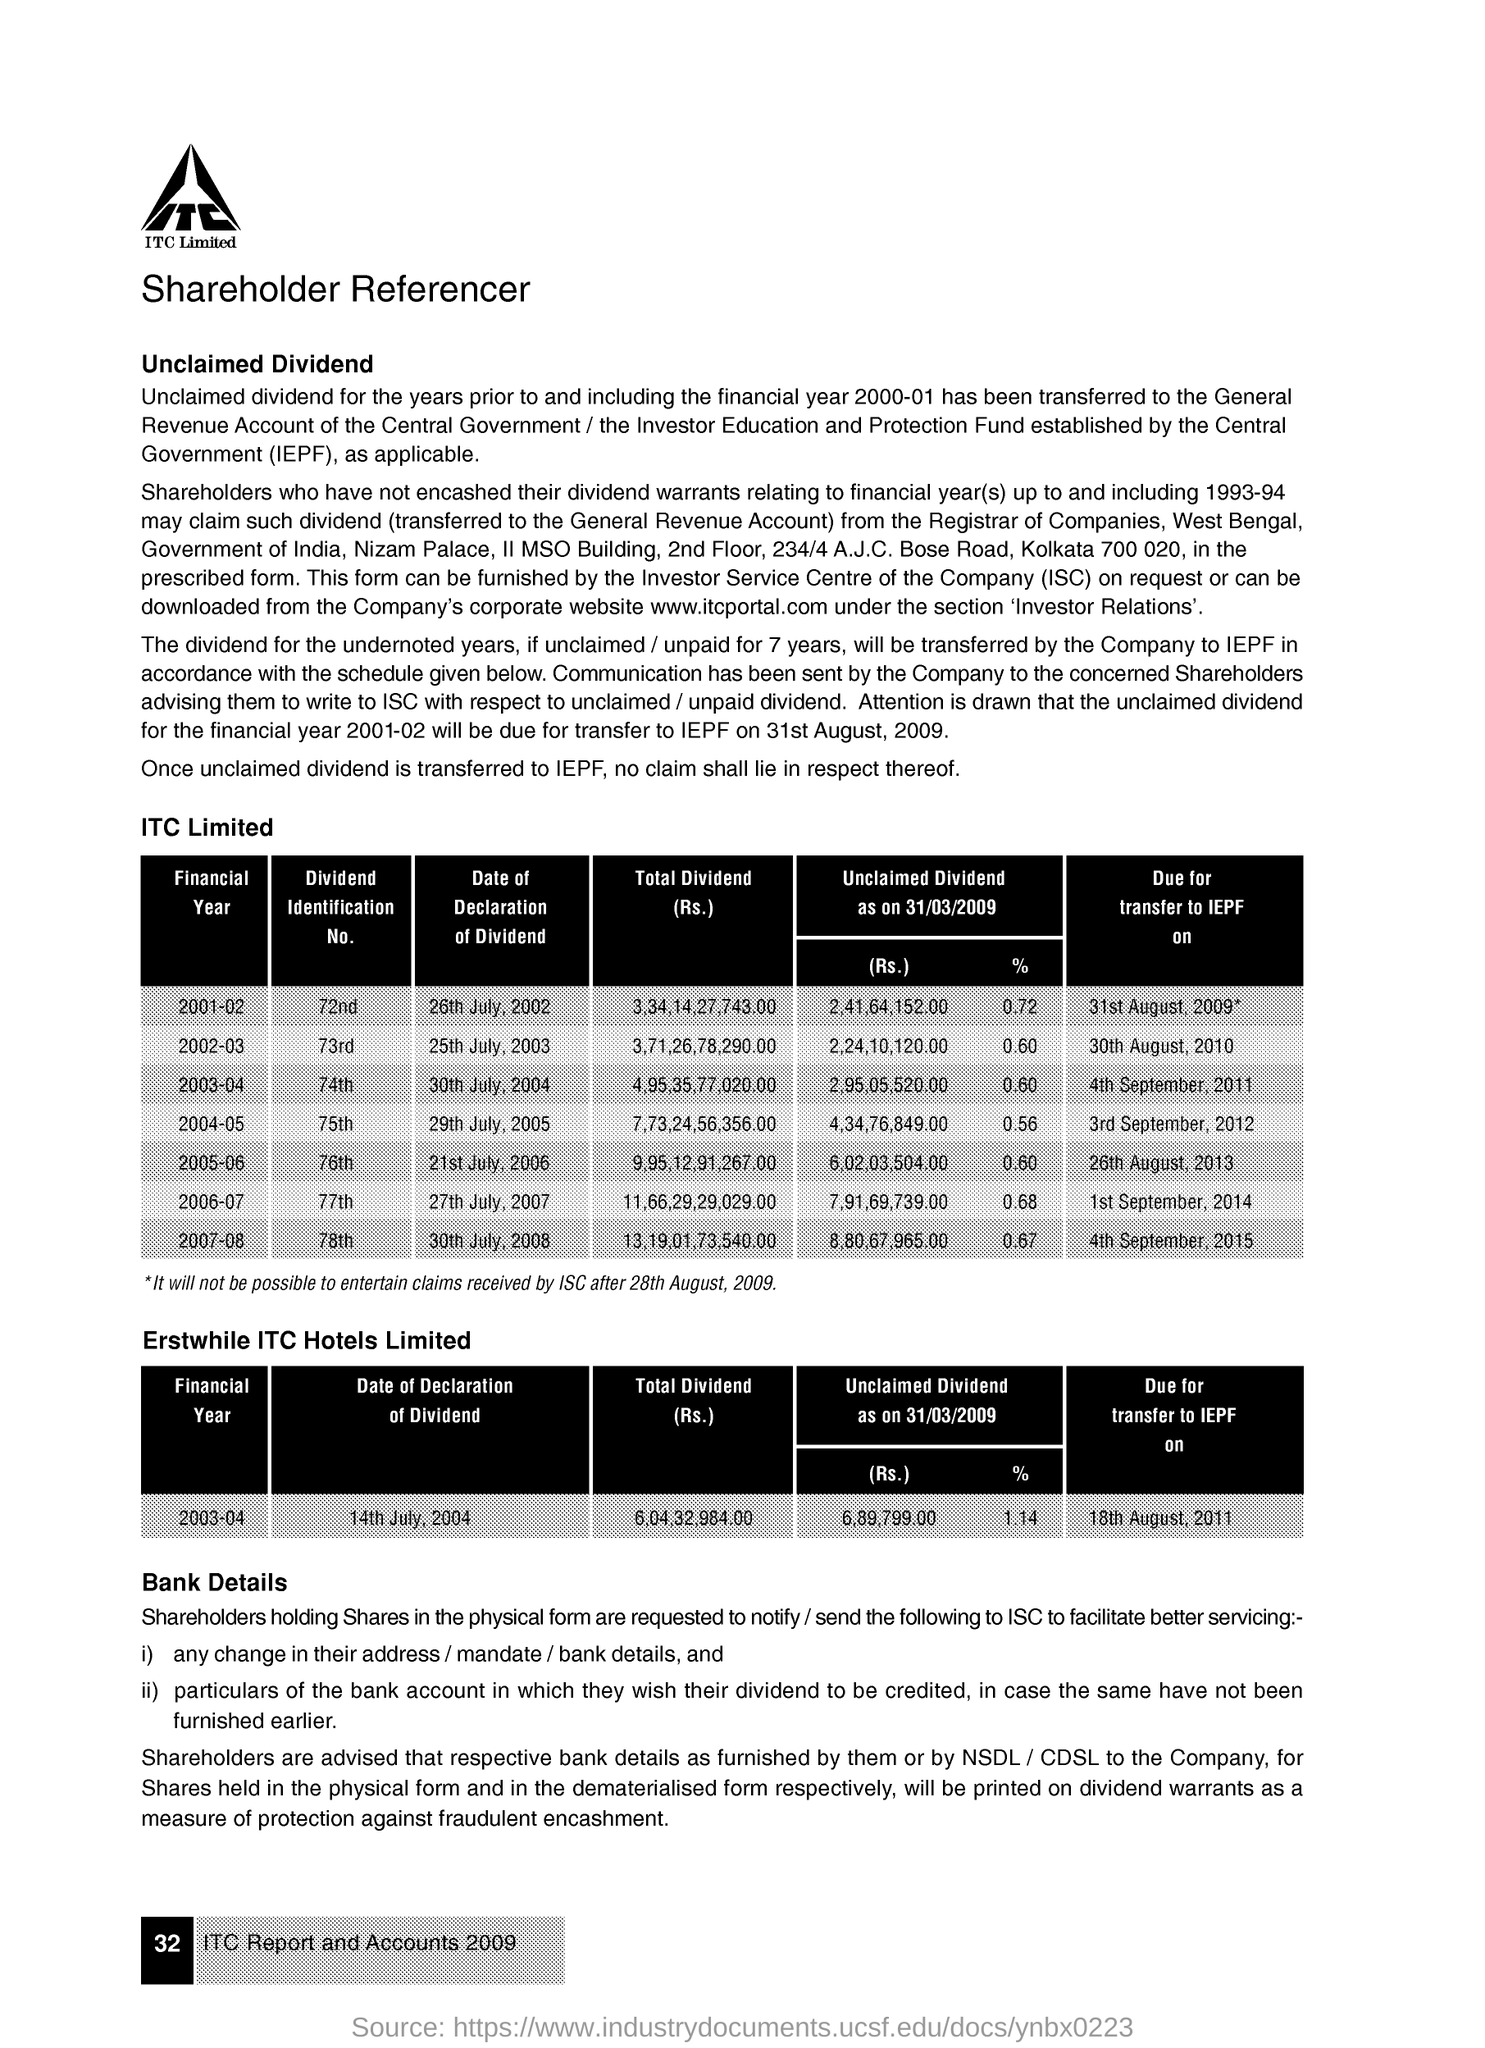List a handful of essential elements in this visual. The dividend identification number for the financial year 2001-02 is 72. On March 31st, 2009, the rate for unclaimed dividends for the financial year 2002-03 was 0.60. As of March 31, 2009, there was an unclaimed dividend of 7,91,69,739.00 for the financial year 2006-07. 